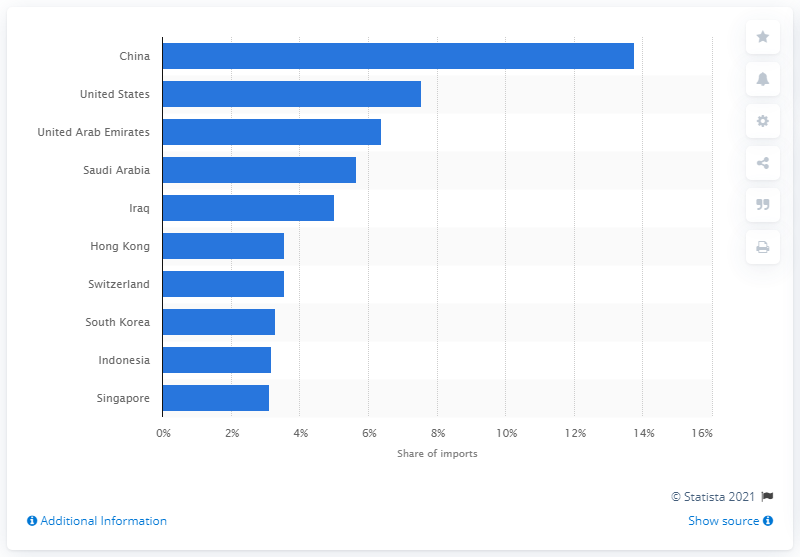Highlight a few significant elements in this photo. India's largest share of imports came from China. In the fiscal year 2020, the major imports of India were shipped to the United States. 